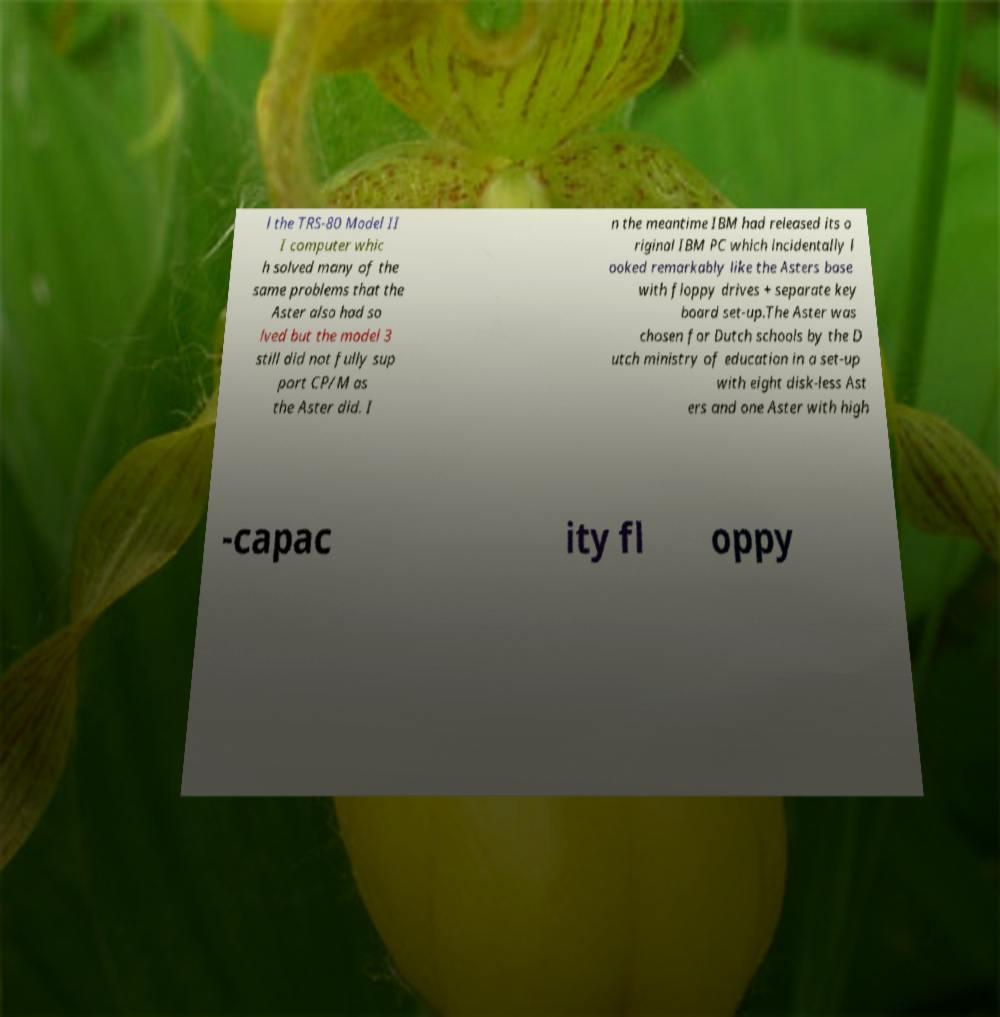For documentation purposes, I need the text within this image transcribed. Could you provide that? l the TRS-80 Model II I computer whic h solved many of the same problems that the Aster also had so lved but the model 3 still did not fully sup port CP/M as the Aster did. I n the meantime IBM had released its o riginal IBM PC which incidentally l ooked remarkably like the Asters base with floppy drives + separate key board set-up.The Aster was chosen for Dutch schools by the D utch ministry of education in a set-up with eight disk-less Ast ers and one Aster with high -capac ity fl oppy 